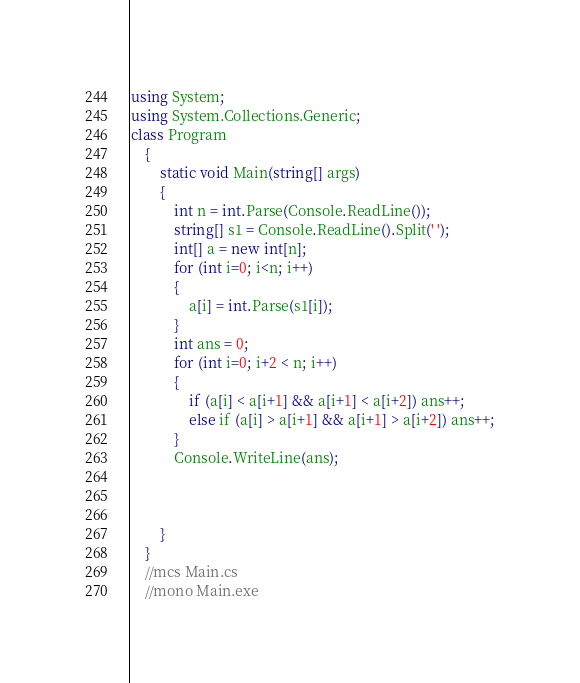<code> <loc_0><loc_0><loc_500><loc_500><_C#_>using System;
using System.Collections.Generic;
class Program
    {
    	static void Main(string[] args)
    	{
            int n = int.Parse(Console.ReadLine());
            string[] s1 = Console.ReadLine().Split(' ');
            int[] a = new int[n];
            for (int i=0; i<n; i++)
            {
                a[i] = int.Parse(s1[i]);
            }
            int ans = 0;
            for (int i=0; i+2 < n; i++)
            {
                if (a[i] < a[i+1] && a[i+1] < a[i+2]) ans++;
                else if (a[i] > a[i+1] && a[i+1] > a[i+2]) ans++;
            }
            Console.WriteLine(ans);

            
            
        }
    }
    //mcs Main.cs
    //mono Main.exe</code> 